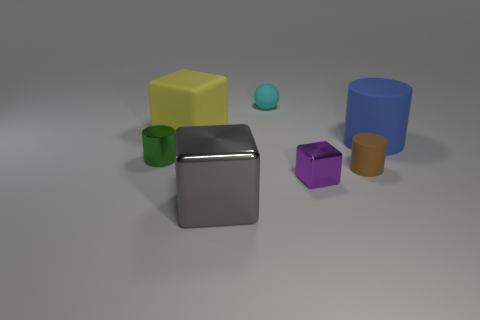What number of other things are the same size as the gray shiny thing? There are two objects that appear to be of similar size to the gray shiny cube: a green cylinder and a purple cube. 